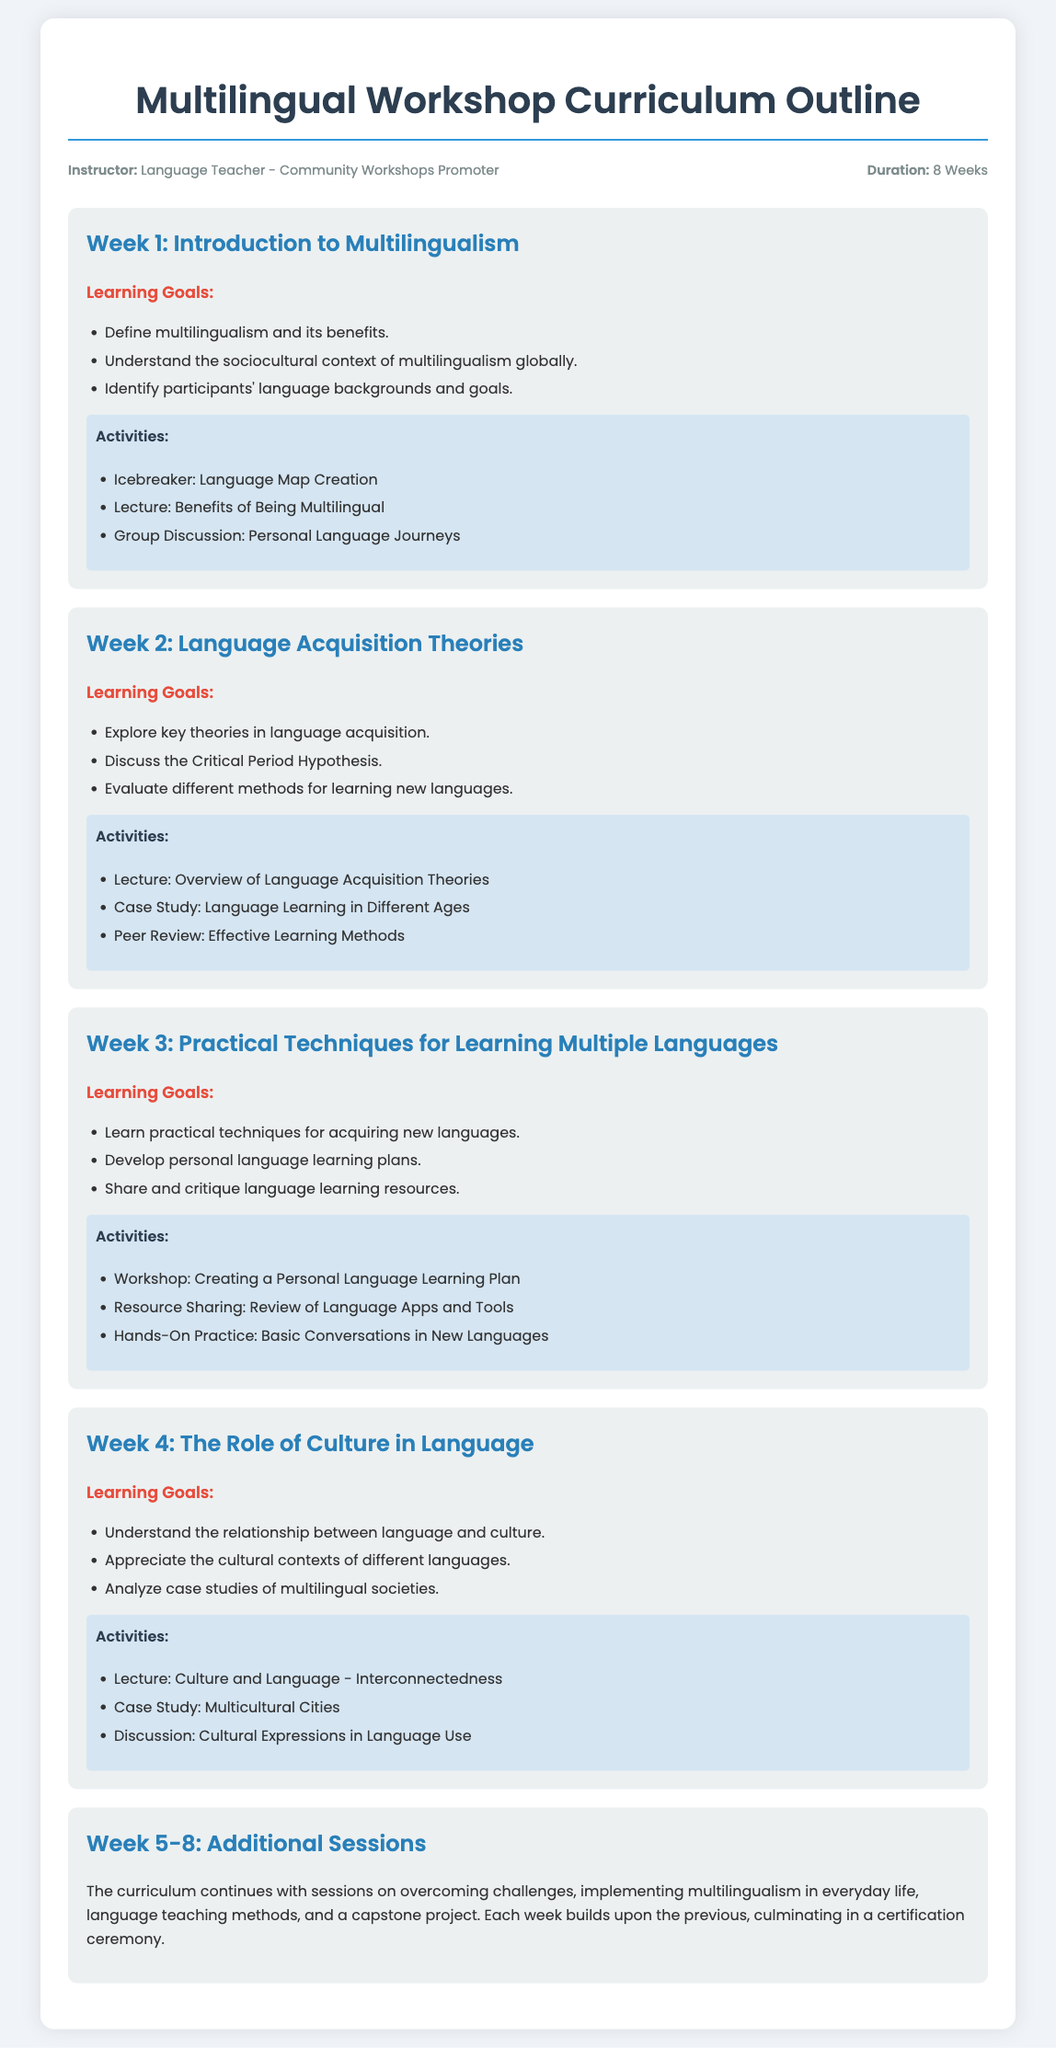what is the total duration of the workshop? The total duration of the workshop is specified as 8 Weeks in the document.
Answer: 8 Weeks who is the instructor of the workshop? The instructor is identified as "Language Teacher - Community Workshops Promoter" in the information section.
Answer: Language Teacher - Community Workshops Promoter what is the learning goal for Week 1? The document lists that participants should "Define multilingualism and its benefits."
Answer: Define multilingualism and its benefits which session discusses the Critical Period Hypothesis? According to the weeks outlined, the session discussing the Critical Period Hypothesis is in Week 2, which focuses on Language Acquisition Theories.
Answer: Week 2 what kind of activity is scheduled for Week 3? The activities in Week 3 include "Workshop: Creating a Personal Language Learning Plan."
Answer: Workshop: Creating a Personal Language Learning Plan how many weeks cover additional sessions? The curriculum continues with additional sessions from Week 5 to Week 8, which accounts for 4 weeks.
Answer: 4 weeks what is a learning goal mentioned for Week 4? One of the learning goals for Week 4 is "Understand the relationship between language and culture."
Answer: Understand the relationship between language and culture what finishes the curriculum outline? The curriculum culminates in a "certification ceremony," which concludes the outline.
Answer: certification ceremony 